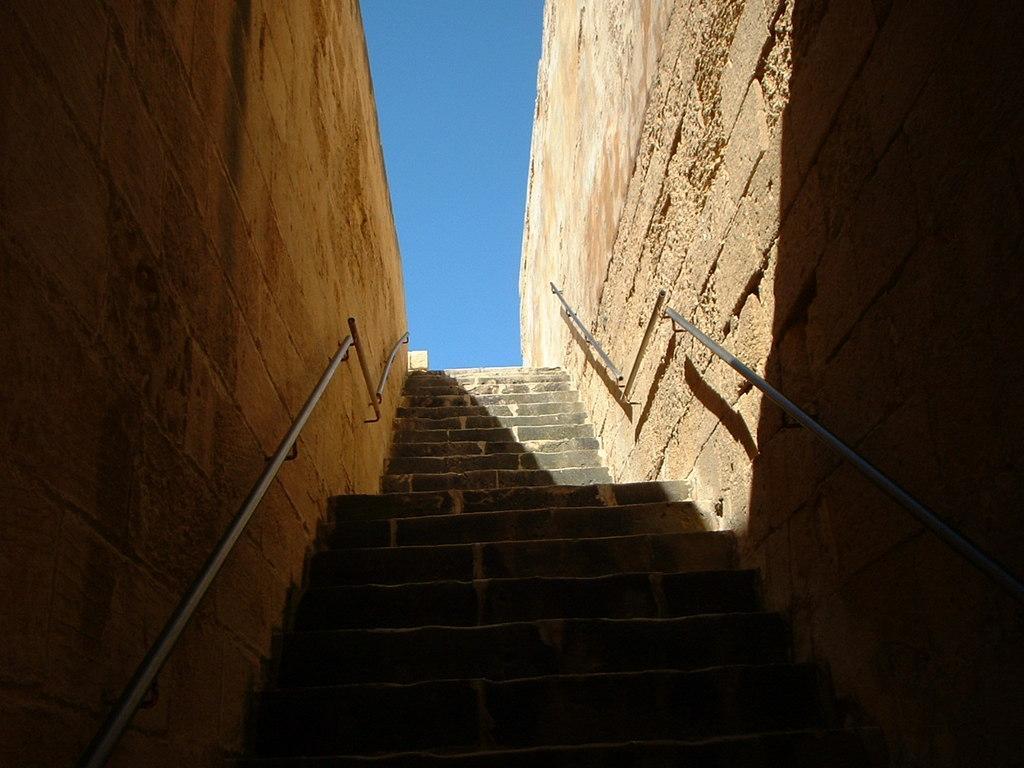Please provide a concise description of this image. In this picture I can see stars, there are staircase holders attached to the walls, and in the background there is the sky. 